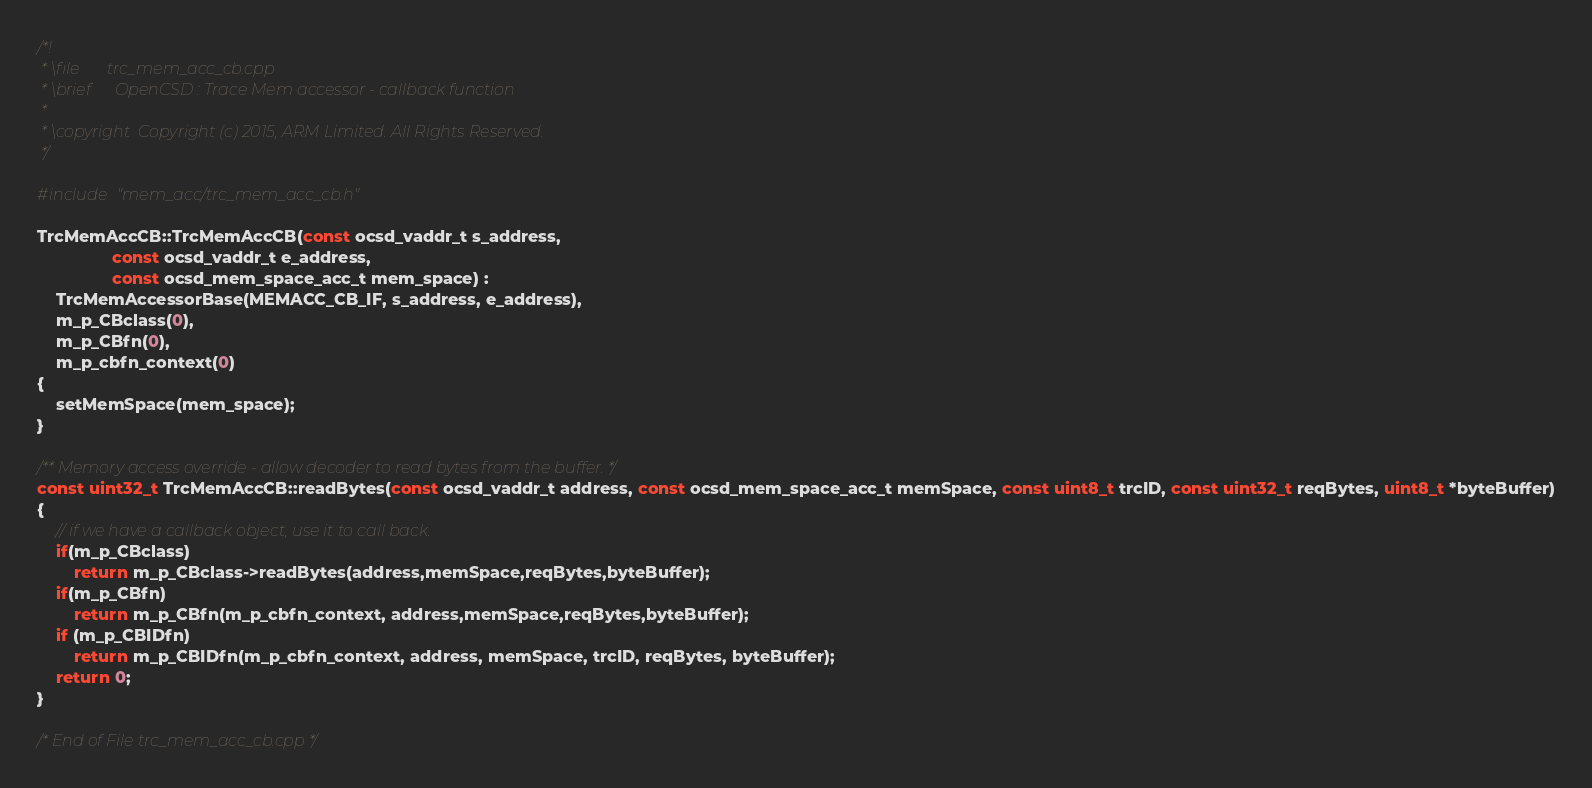Convert code to text. <code><loc_0><loc_0><loc_500><loc_500><_C++_>/*!
 * \file       trc_mem_acc_cb.cpp
 * \brief      OpenCSD : Trace Mem accessor - callback function
 * 
 * \copyright  Copyright (c) 2015, ARM Limited. All Rights Reserved.
 */

#include "mem_acc/trc_mem_acc_cb.h"

TrcMemAccCB::TrcMemAccCB(const ocsd_vaddr_t s_address, 
                const ocsd_vaddr_t e_address, 
                const ocsd_mem_space_acc_t mem_space) : 
    TrcMemAccessorBase(MEMACC_CB_IF, s_address, e_address),
    m_p_CBclass(0),
    m_p_CBfn(0),
    m_p_cbfn_context(0)
{
    setMemSpace(mem_space);    
}

/** Memory access override - allow decoder to read bytes from the buffer. */
const uint32_t TrcMemAccCB::readBytes(const ocsd_vaddr_t address, const ocsd_mem_space_acc_t memSpace, const uint8_t trcID, const uint32_t reqBytes, uint8_t *byteBuffer)
{
    // if we have a callback object, use it to call back.
    if(m_p_CBclass)
        return m_p_CBclass->readBytes(address,memSpace,reqBytes,byteBuffer);
    if(m_p_CBfn)
        return m_p_CBfn(m_p_cbfn_context, address,memSpace,reqBytes,byteBuffer);
    if (m_p_CBIDfn)
        return m_p_CBIDfn(m_p_cbfn_context, address, memSpace, trcID, reqBytes, byteBuffer);
    return 0;
}

/* End of File trc_mem_acc_cb.cpp */
</code> 